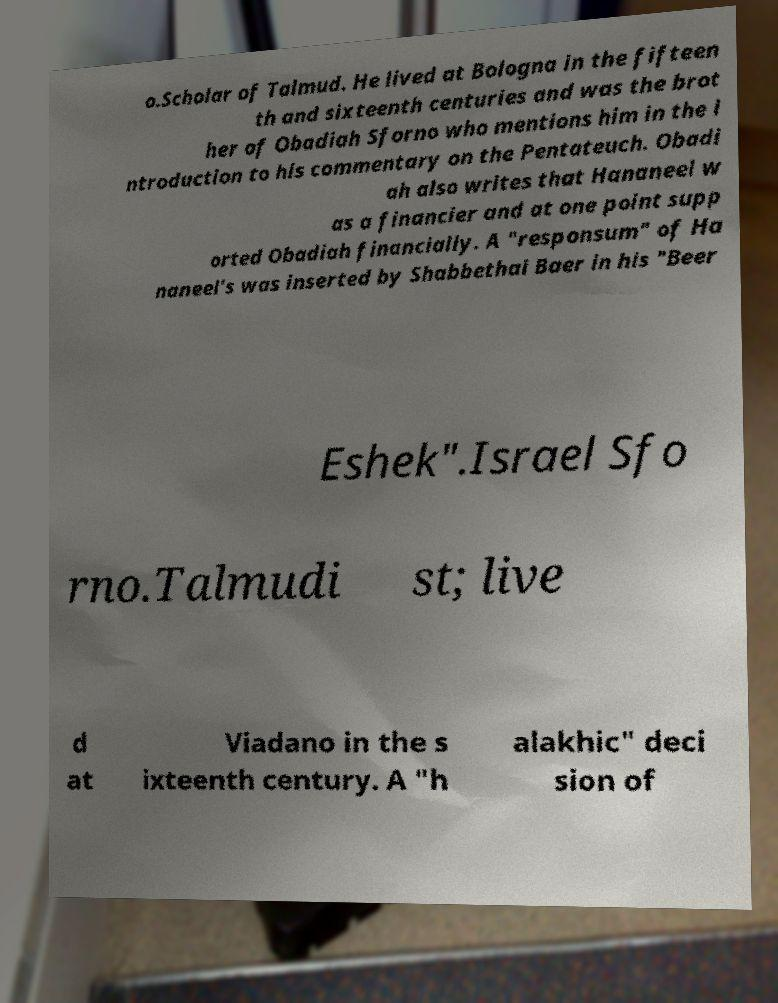Can you accurately transcribe the text from the provided image for me? o.Scholar of Talmud. He lived at Bologna in the fifteen th and sixteenth centuries and was the brot her of Obadiah Sforno who mentions him in the i ntroduction to his commentary on the Pentateuch. Obadi ah also writes that Hananeel w as a financier and at one point supp orted Obadiah financially. A "responsum" of Ha naneel's was inserted by Shabbethai Baer in his "Beer Eshek".Israel Sfo rno.Talmudi st; live d at Viadano in the s ixteenth century. A "h alakhic" deci sion of 